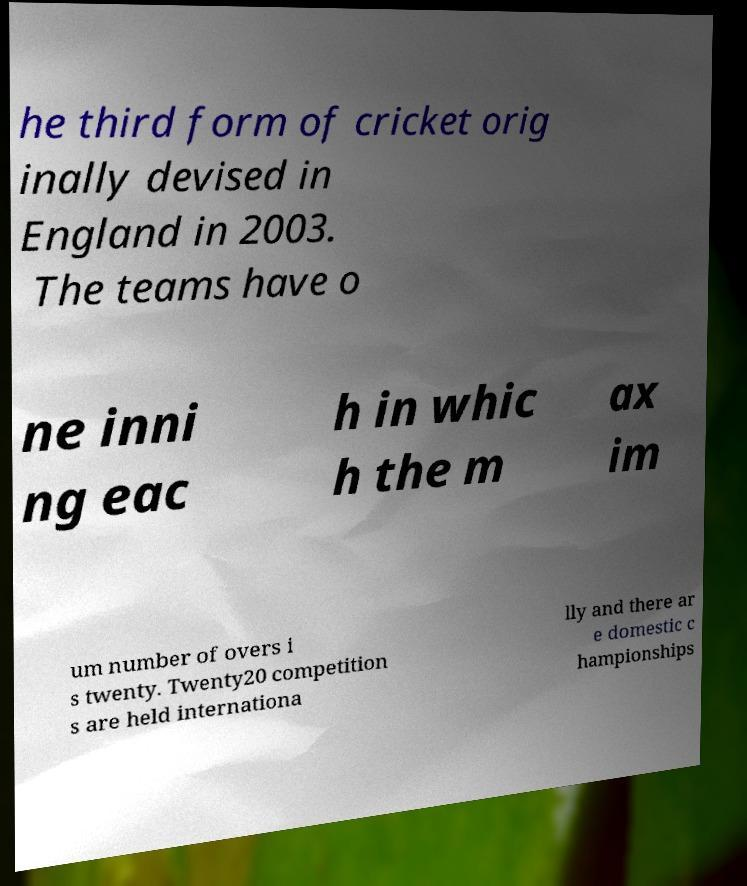For documentation purposes, I need the text within this image transcribed. Could you provide that? he third form of cricket orig inally devised in England in 2003. The teams have o ne inni ng eac h in whic h the m ax im um number of overs i s twenty. Twenty20 competition s are held internationa lly and there ar e domestic c hampionships 